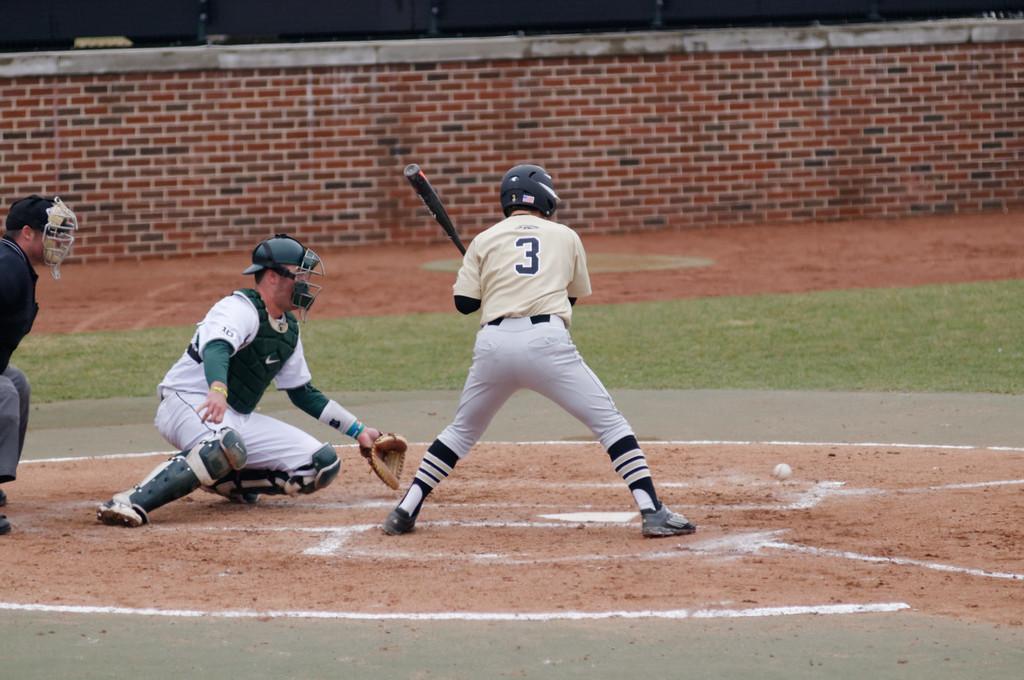What is the number of the player who is batting?
Your answer should be very brief. 3. 